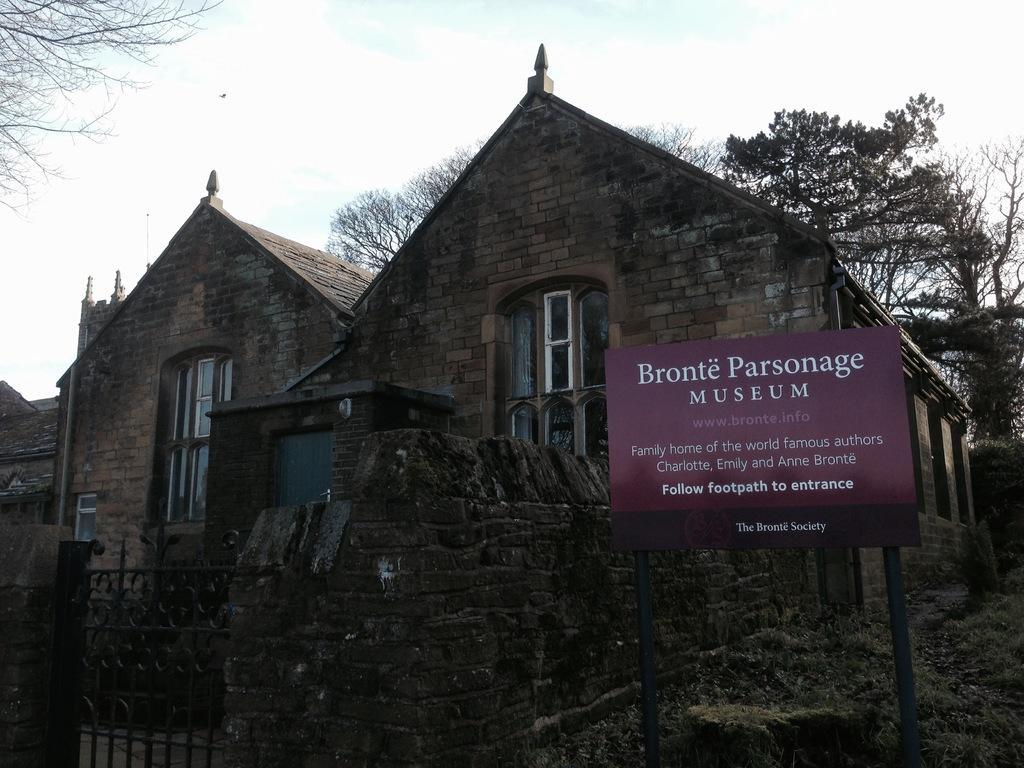Please provide a concise description of this image. In this image we can see houses, windows, gate, wall, board, and trees. In the background there is sky with clouds. 